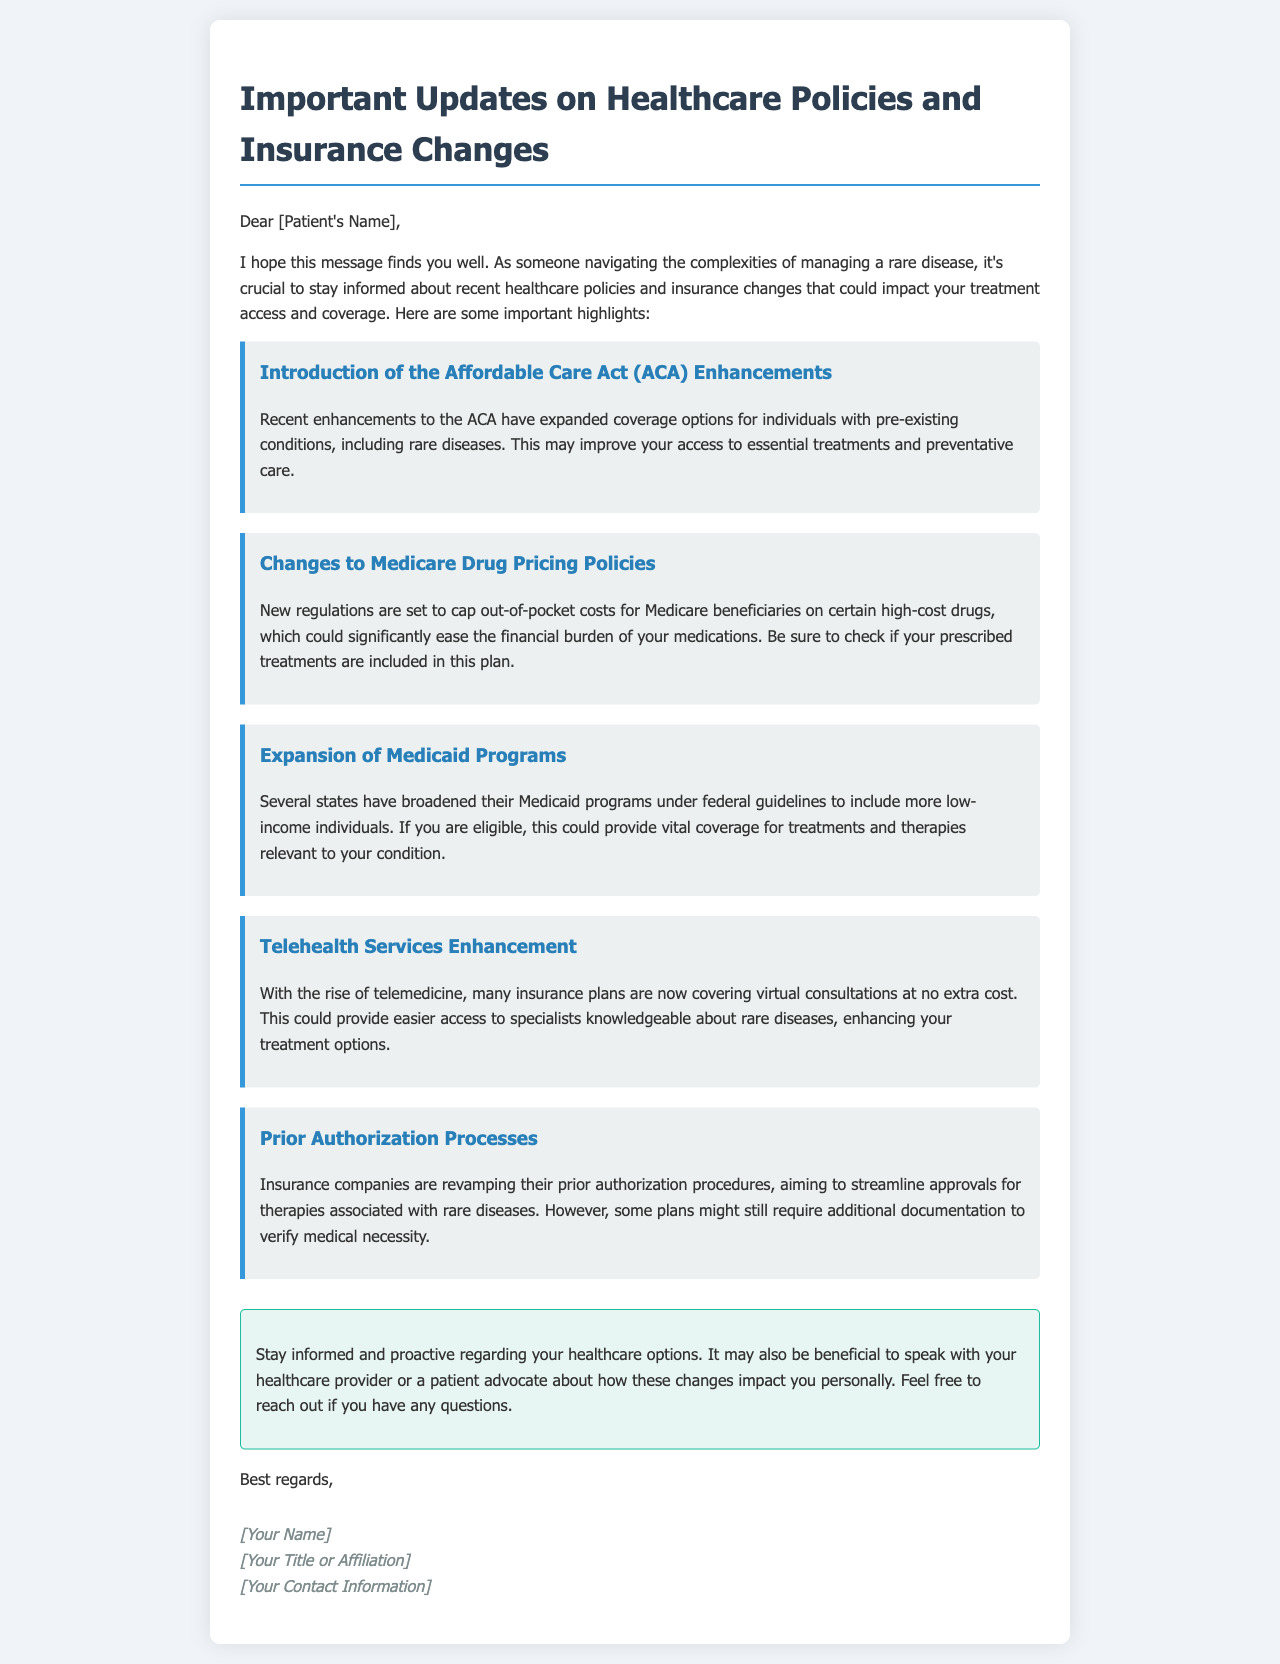What are the recent enhancements to the ACA? The document states that the recent enhancements to the ACA have expanded coverage options for individuals with pre-existing conditions, including rare diseases.
Answer: Expanded coverage options What are the new regulations regarding Medicare drug pricing? The document mentions that new regulations are set to cap out-of-pocket costs for Medicare beneficiaries on certain high-cost drugs.
Answer: Cap costs What has been expanded under Medicaid programs? The document states that several states have broadened their Medicaid programs to include more low-income individuals.
Answer: Broadened Medicaid programs How are telehealth services being affected? The document indicates that many insurance plans are now covering virtual consultations at no extra cost.
Answer: Covered at no extra cost What is the aim of revamping prior authorization processes? The document explains that insurance companies are aiming to streamline approvals for therapies associated with rare diseases.
Answer: Streamline approvals How can patients verify their medication's inclusion in new policies? The document advises that patients should check if their prescribed treatments are included in the new Medicare drug pricing plan.
Answer: Check with the plan What is the recommendation for patients regarding healthcare options? The conclusion in the document suggests that patients should stay informed and proactive regarding their healthcare options.
Answer: Stay informed Who should patients speak to about the impact of changes on their care? The document recommends speaking with healthcare providers or a patient advocate.
Answer: Healthcare provider or patient advocate 